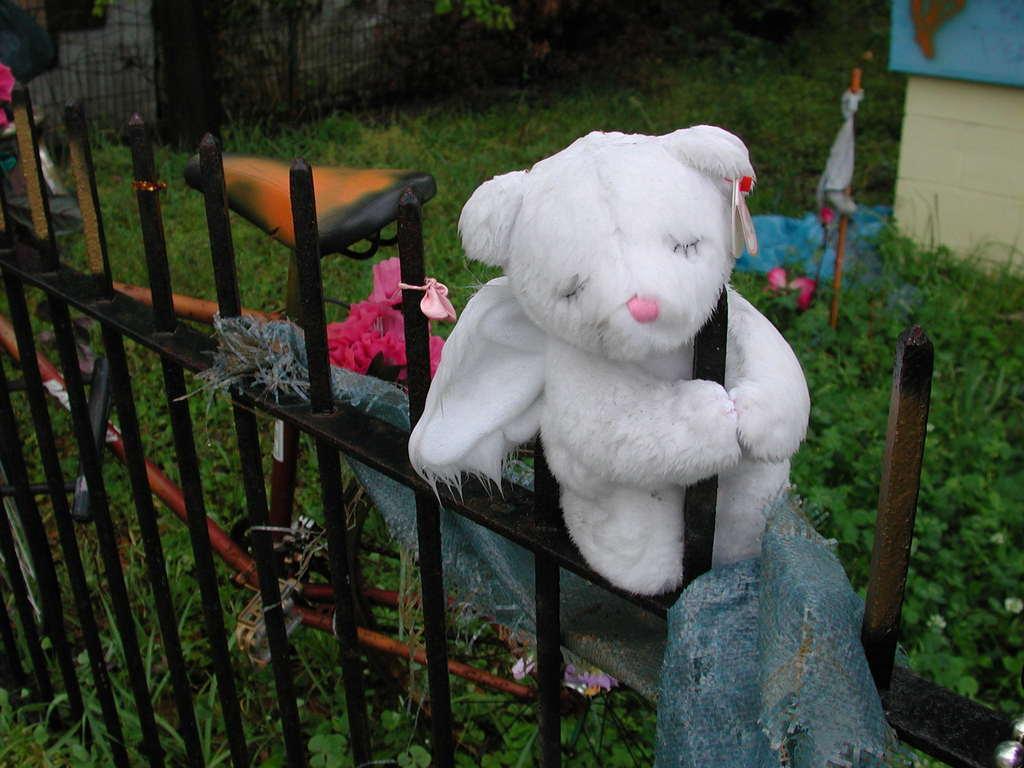Could you give a brief overview of what you see in this image? In this image in front there is a metal fence and there is a toy and a cloth on the metal fence. There is a cycle. At the bottom of the image there is grass on the surface. 